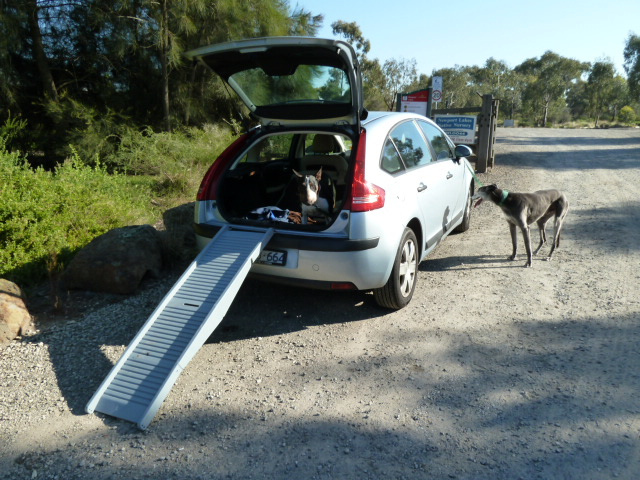If the ramp was designed for a different animal or creature, what changes would be necessary? If the ramp was redesigned for a different animal, such as a cat or a goat, the changes would need to accommodate their specific physical requirements and behaviors. For a cat, the ramp might include textured surfaces for better grip, gentle angles to prevent slipping, and side barriers to make the cat feel more secure. For a goat, the ramp would need to be sturdier to support its weight and possible bouncing, with a non-slip surface to handle hooves appropriately. 